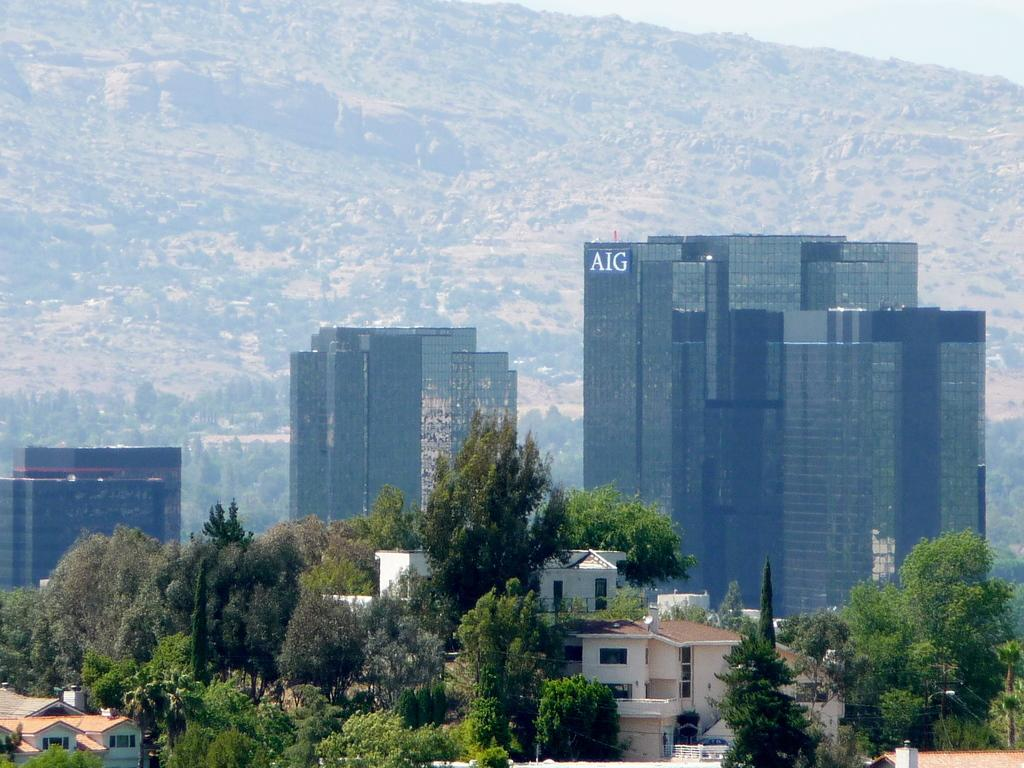What type of building is in the image? There is a big glass building in the image. What can be seen at the front bottom side of the image? There are many trees and small shed houses in the front bottom side of the image. What is visible in the background of the image? There is a huge rock mountain in the background of the image. How many lifts are available inside the glass building? There is no information about the number of lifts inside the glass building in the image. What type of rail can be seen connecting the trees and the shed houses? There is no rail connecting the trees and the shed houses in the image. 